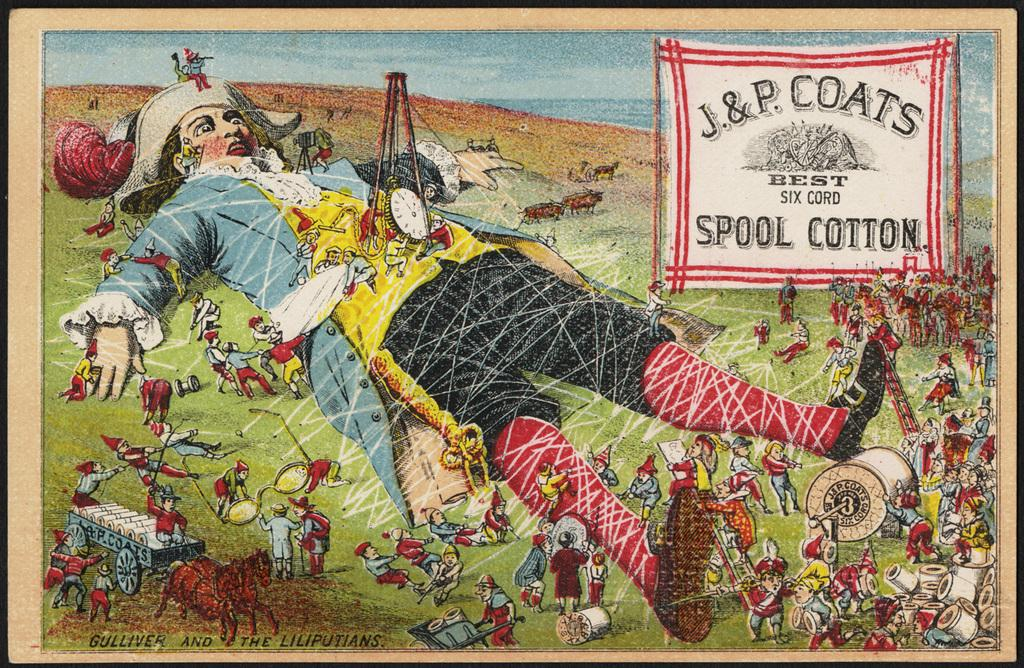<image>
Share a concise interpretation of the image provided. A Gulliver's Travels themed advertisement is for J & P Coats Spool Cotton. 